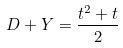<formula> <loc_0><loc_0><loc_500><loc_500>D + Y = \frac { t ^ { 2 } + t } { 2 }</formula> 